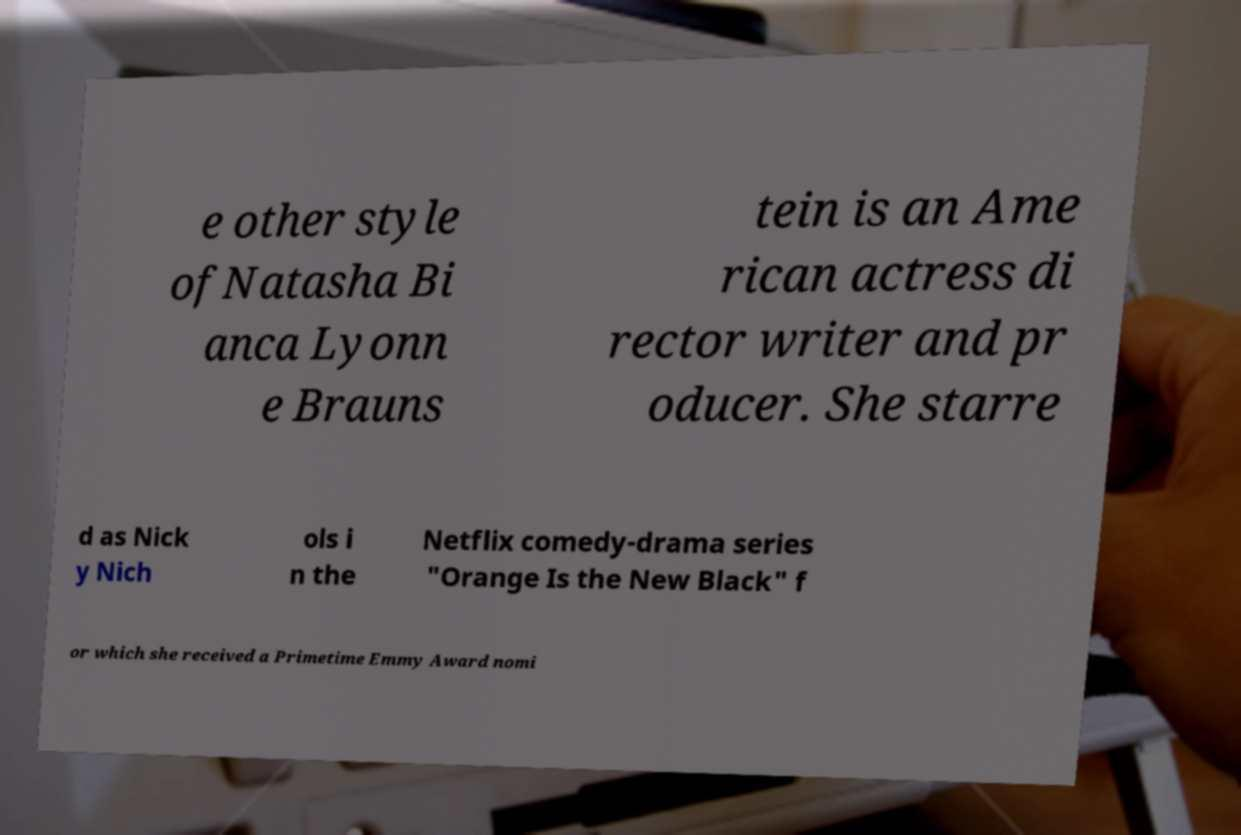Can you read and provide the text displayed in the image?This photo seems to have some interesting text. Can you extract and type it out for me? e other style ofNatasha Bi anca Lyonn e Brauns tein is an Ame rican actress di rector writer and pr oducer. She starre d as Nick y Nich ols i n the Netflix comedy-drama series "Orange Is the New Black" f or which she received a Primetime Emmy Award nomi 